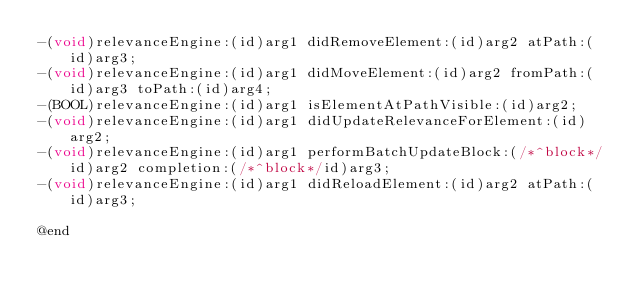<code> <loc_0><loc_0><loc_500><loc_500><_C_>-(void)relevanceEngine:(id)arg1 didRemoveElement:(id)arg2 atPath:(id)arg3;
-(void)relevanceEngine:(id)arg1 didMoveElement:(id)arg2 fromPath:(id)arg3 toPath:(id)arg4;
-(BOOL)relevanceEngine:(id)arg1 isElementAtPathVisible:(id)arg2;
-(void)relevanceEngine:(id)arg1 didUpdateRelevanceForElement:(id)arg2;
-(void)relevanceEngine:(id)arg1 performBatchUpdateBlock:(/*^block*/id)arg2 completion:(/*^block*/id)arg3;
-(void)relevanceEngine:(id)arg1 didReloadElement:(id)arg2 atPath:(id)arg3;

@end

</code> 